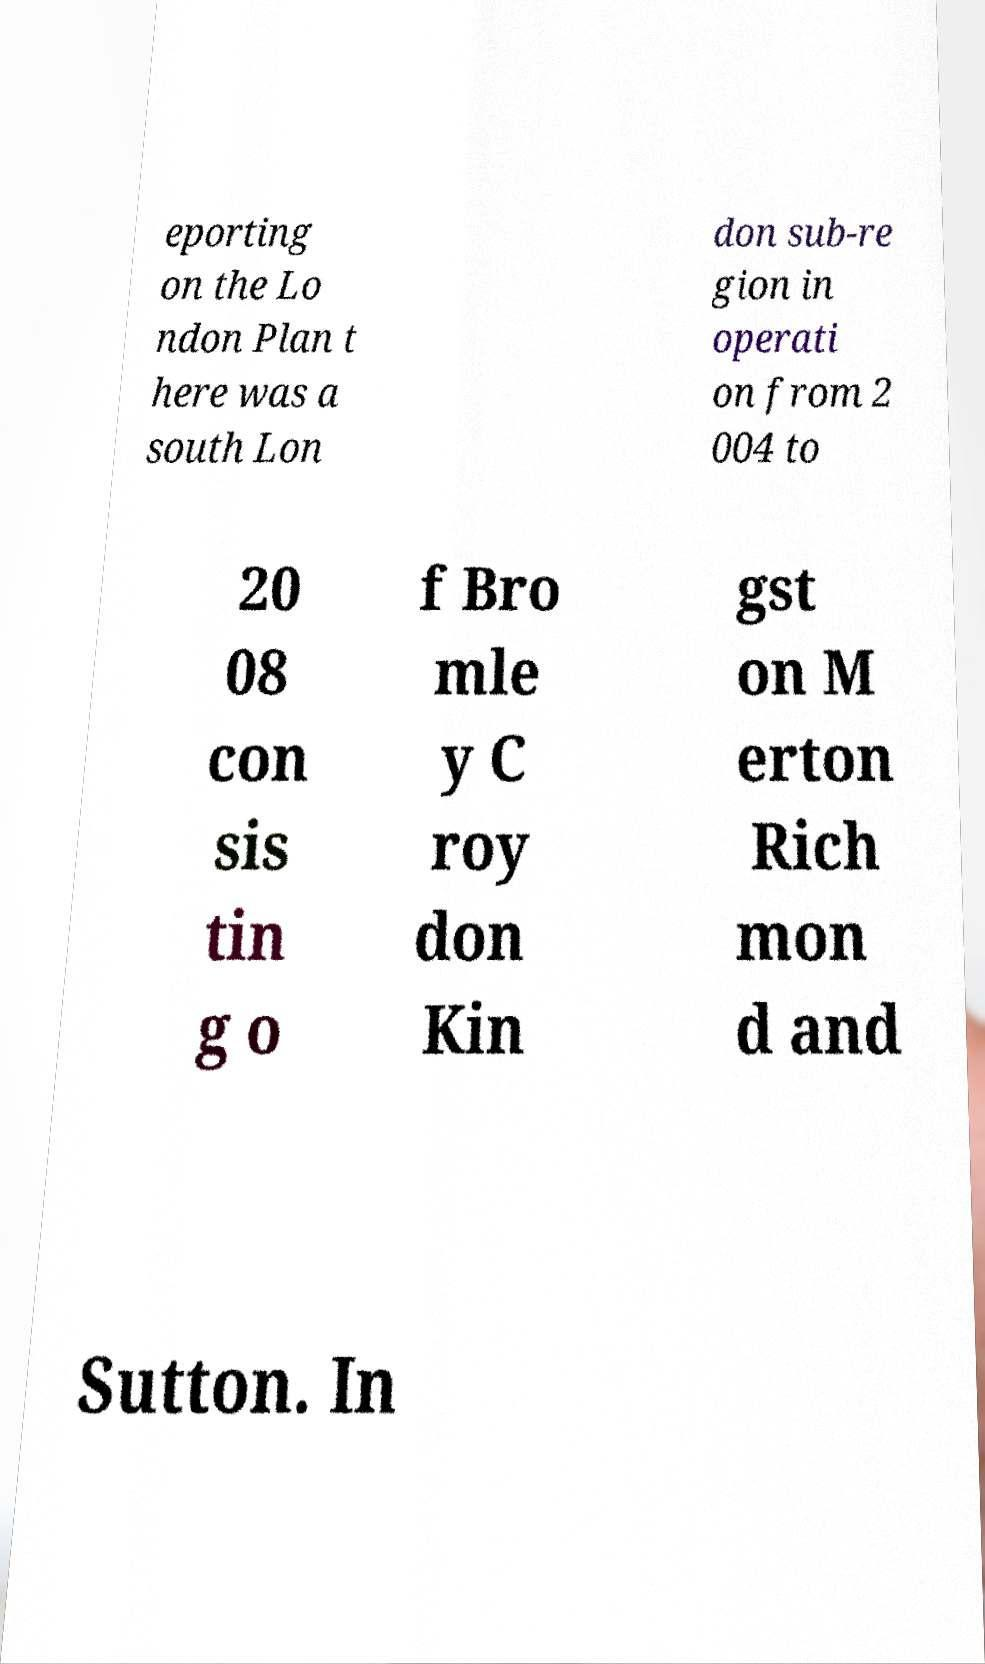Can you accurately transcribe the text from the provided image for me? eporting on the Lo ndon Plan t here was a south Lon don sub-re gion in operati on from 2 004 to 20 08 con sis tin g o f Bro mle y C roy don Kin gst on M erton Rich mon d and Sutton. In 